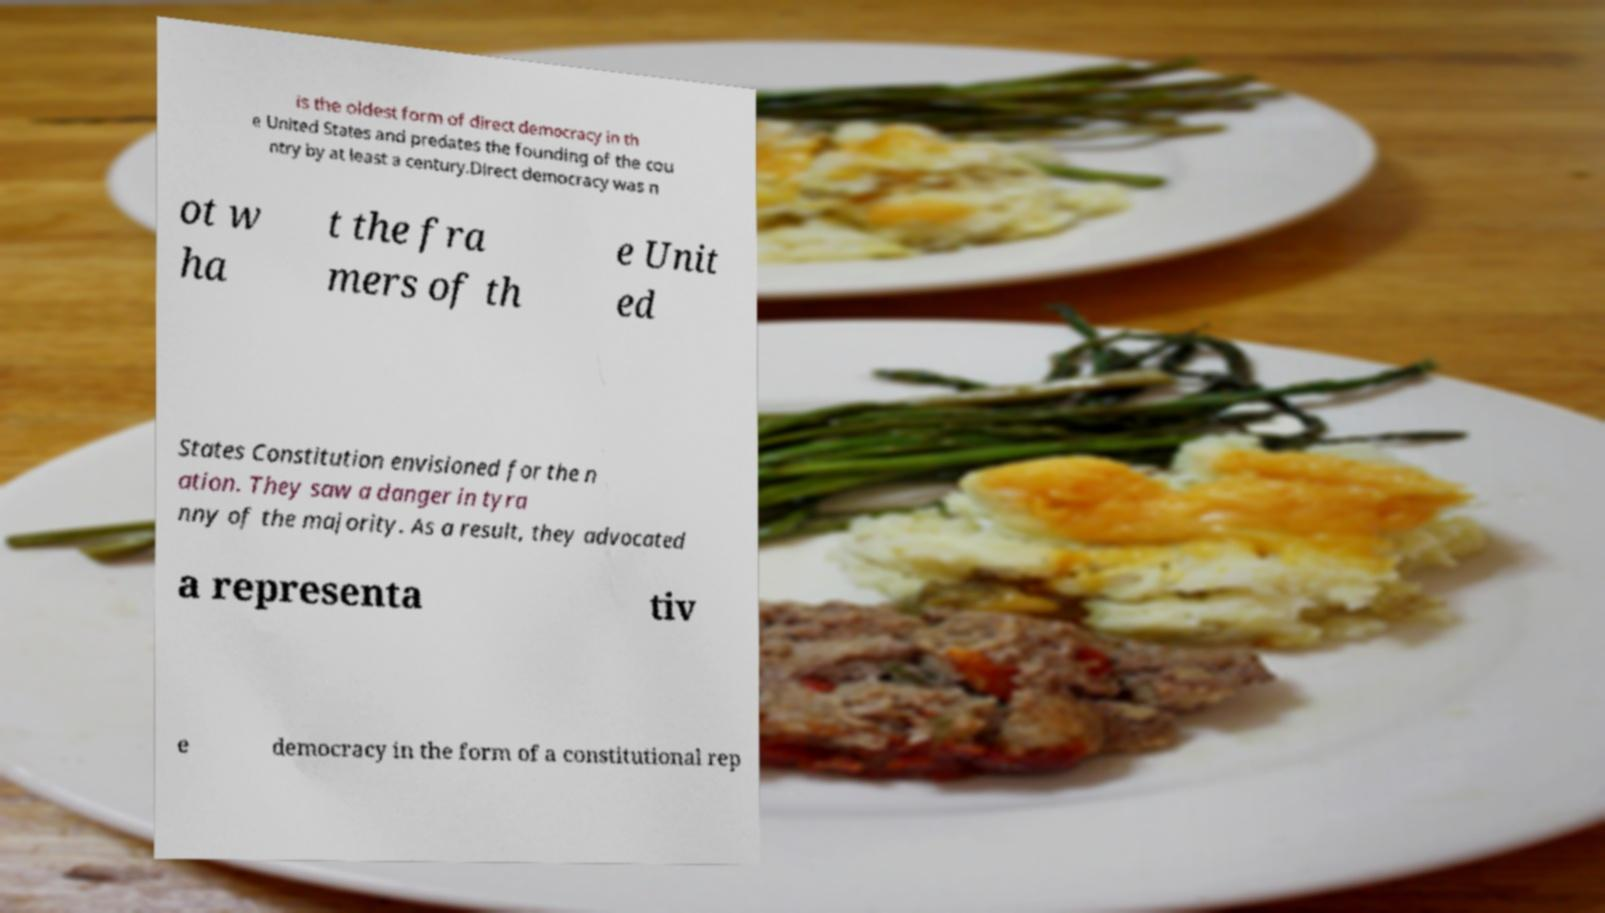Could you assist in decoding the text presented in this image and type it out clearly? is the oldest form of direct democracy in th e United States and predates the founding of the cou ntry by at least a century.Direct democracy was n ot w ha t the fra mers of th e Unit ed States Constitution envisioned for the n ation. They saw a danger in tyra nny of the majority. As a result, they advocated a representa tiv e democracy in the form of a constitutional rep 